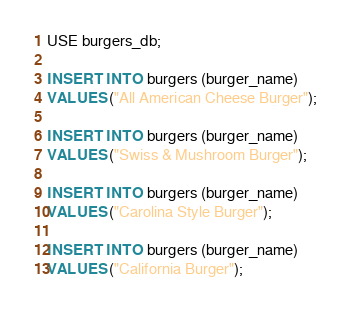Convert code to text. <code><loc_0><loc_0><loc_500><loc_500><_SQL_>USE burgers_db;

INSERT INTO burgers (burger_name)
VALUES ("All American Cheese Burger");

INSERT INTO burgers (burger_name)
VALUES ("Swiss & Mushroom Burger");

INSERT INTO burgers (burger_name)
VALUES ("Carolina Style Burger");

INSERT INTO burgers (burger_name)
VALUES ("California Burger");</code> 